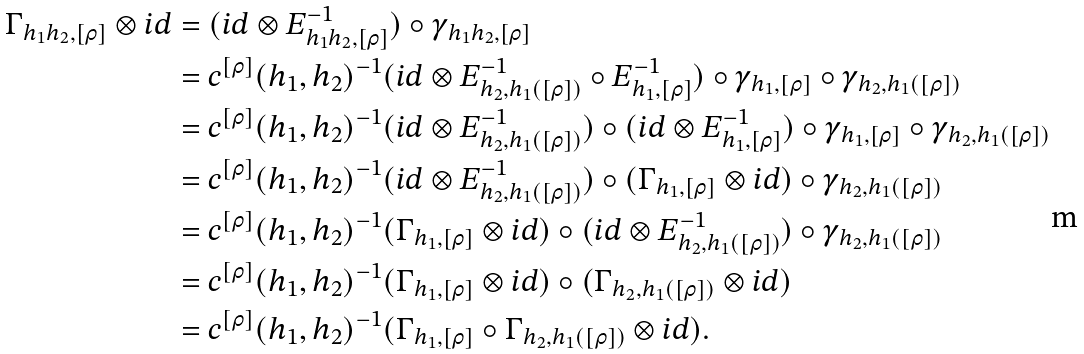Convert formula to latex. <formula><loc_0><loc_0><loc_500><loc_500>\Gamma _ { h _ { 1 } h _ { 2 } , [ \rho ] } \otimes i d & = ( i d \otimes E _ { h _ { 1 } h _ { 2 } , [ \rho ] } ^ { - 1 } ) \circ \gamma _ { h _ { 1 } h _ { 2 } , [ \rho ] } \\ & = c ^ { [ \rho ] } ( h _ { 1 } , h _ { 2 } ) ^ { - 1 } ( i d \otimes E _ { h _ { 2 } , h _ { 1 } ( [ \rho ] ) } ^ { - 1 } \circ E _ { h _ { 1 } , [ \rho ] } ^ { - 1 } ) \circ \gamma _ { h _ { 1 } , [ \rho ] } \circ \gamma _ { h _ { 2 } , h _ { 1 } ( [ \rho ] ) } \\ & = c ^ { [ \rho ] } ( h _ { 1 } , h _ { 2 } ) ^ { - 1 } ( i d \otimes E _ { h _ { 2 } , h _ { 1 } ( [ \rho ] ) } ^ { - 1 } ) \circ ( i d \otimes E _ { h _ { 1 } , [ \rho ] } ^ { - 1 } ) \circ \gamma _ { h _ { 1 } , [ \rho ] } \circ \gamma _ { h _ { 2 } , h _ { 1 } ( [ \rho ] ) } \\ & = c ^ { [ \rho ] } ( h _ { 1 } , h _ { 2 } ) ^ { - 1 } ( i d \otimes E _ { h _ { 2 } , h _ { 1 } ( [ \rho ] ) } ^ { - 1 } ) \circ ( \Gamma _ { h _ { 1 } , [ \rho ] } \otimes i d ) \circ \gamma _ { h _ { 2 } , h _ { 1 } ( [ \rho ] ) } \\ & = c ^ { [ \rho ] } ( h _ { 1 } , h _ { 2 } ) ^ { - 1 } ( \Gamma _ { h _ { 1 } , [ \rho ] } \otimes i d ) \circ ( i d \otimes E _ { h _ { 2 } , h _ { 1 } ( [ \rho ] ) } ^ { - 1 } ) \circ \gamma _ { h _ { 2 } , h _ { 1 } ( [ \rho ] ) } \\ & = c ^ { [ \rho ] } ( h _ { 1 } , h _ { 2 } ) ^ { - 1 } ( \Gamma _ { h _ { 1 } , [ \rho ] } \otimes i d ) \circ ( \Gamma _ { h _ { 2 } , h _ { 1 } ( [ \rho ] ) } \otimes i d ) \\ & = c ^ { [ \rho ] } ( h _ { 1 } , h _ { 2 } ) ^ { - 1 } ( \Gamma _ { h _ { 1 } , [ \rho ] } \circ \Gamma _ { h _ { 2 } , h _ { 1 } ( [ \rho ] ) } \otimes i d ) .</formula> 